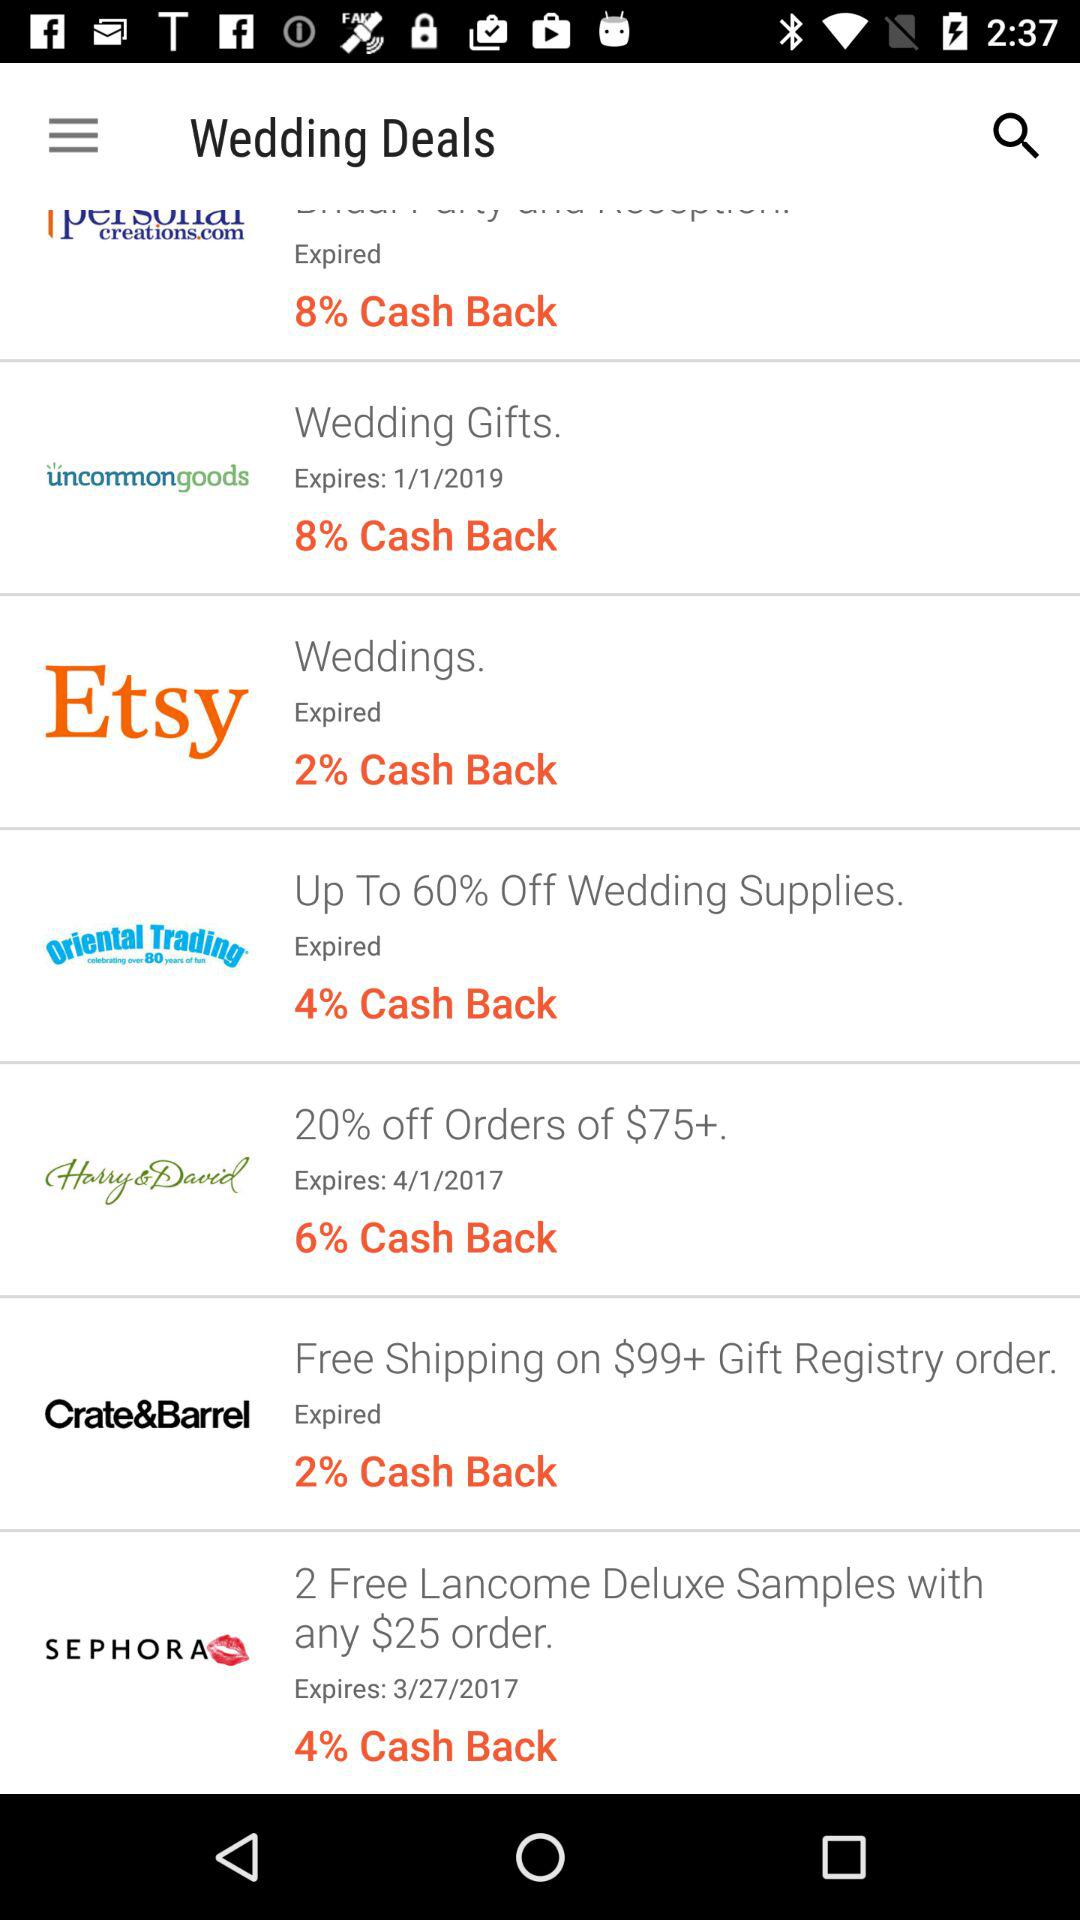How much cashback is on "Wedding Gifts"? The cashback is 8%. 